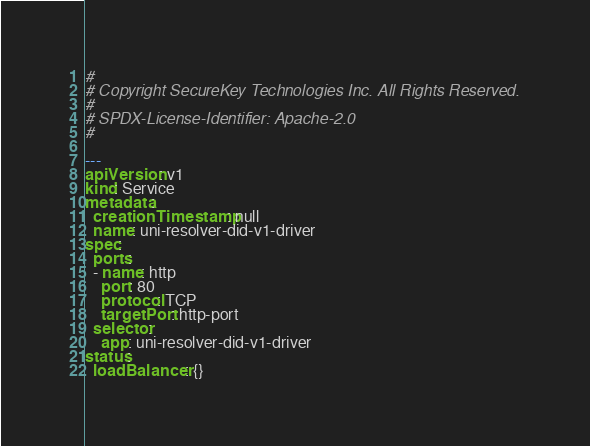Convert code to text. <code><loc_0><loc_0><loc_500><loc_500><_YAML_># 
# Copyright SecureKey Technologies Inc. All Rights Reserved. 
# 
# SPDX-License-Identifier: Apache-2.0 
# 

---
apiVersion: v1
kind: Service
metadata:
  creationTimestamp: null
  name: uni-resolver-did-v1-driver
spec:
  ports:
  - name: http
    port: 80
    protocol: TCP
    targetPort: http-port
  selector:
    app: uni-resolver-did-v1-driver
status:
  loadBalancer: {}
</code> 